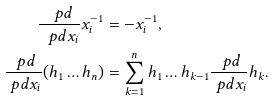<formula> <loc_0><loc_0><loc_500><loc_500>\frac { \ p d } { \ p d x _ { i } } x _ { i } ^ { - 1 } & = - x _ { i } ^ { - 1 } , \\ \frac { \ p d } { \ p d x _ { i } } ( h _ { 1 } \dots h _ { n } ) & = \sum _ { k = 1 } ^ { n } h _ { 1 } \dots h _ { k - 1 } \frac { \ p d } { \ p d x _ { i } } h _ { k } .</formula> 